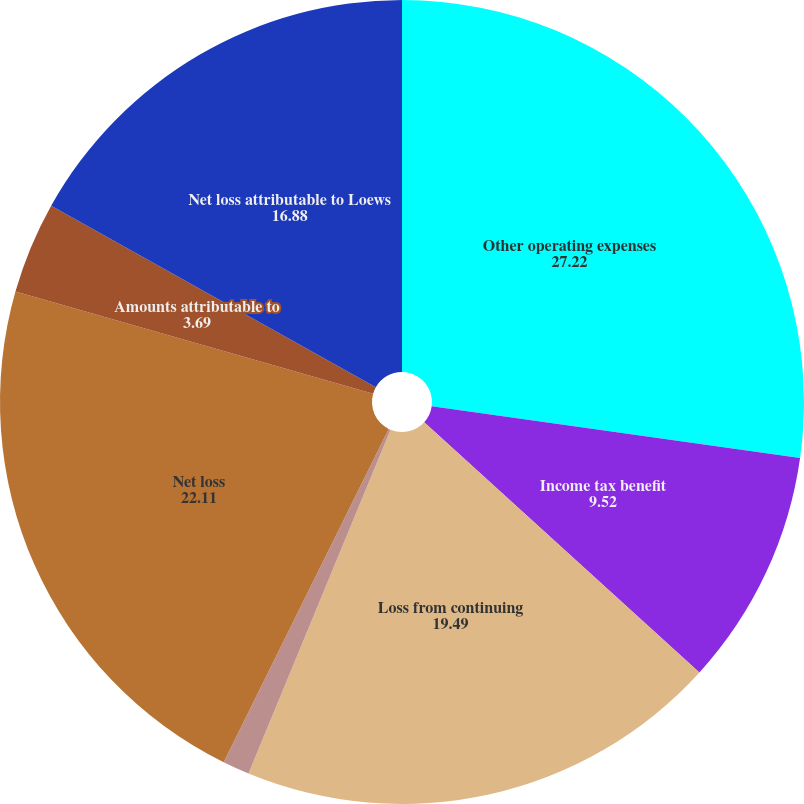<chart> <loc_0><loc_0><loc_500><loc_500><pie_chart><fcel>Other operating expenses<fcel>Income tax benefit<fcel>Loss from continuing<fcel>Loss from discontinued<fcel>Net loss<fcel>Amounts attributable to<fcel>Net loss attributable to Loews<nl><fcel>27.22%<fcel>9.52%<fcel>19.49%<fcel>1.08%<fcel>22.11%<fcel>3.69%<fcel>16.88%<nl></chart> 